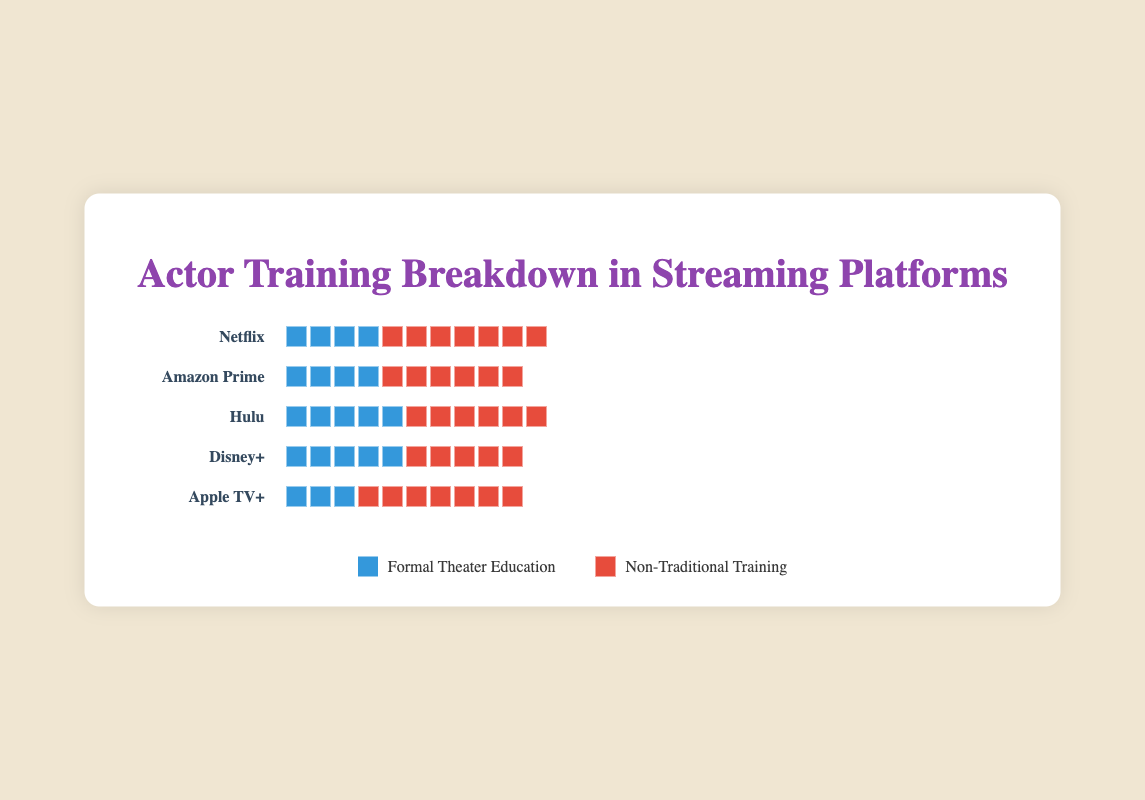Which streaming platform has the highest percentage of actors with formal theater education? To find this, look at each row and count the number of icons representing actors with formal theater education. The platform with the most icons in the "formal" category is Disney+ with 50 actors.
Answer: Disney+ What is the percentage difference in actors with non-traditional training between Netflix and Apple TV+? Count the icons for non-traditional training on both Netflix and Apple TV+. For Netflix, there are 65, and for Apple TV+, there are 70. The percentage difference is (70 - 65) / 100 * 100% = 5%.
Answer: 5% Which platform has an equal number of actors with formal theater education and non-traditional training? Look for a platform whose icons for formal theater education and non-traditional training are equal. Disney+ has 50 for each, making them equal.
Answer: Disney+ How many more actors have non-traditional training than formal theater education on Amazon Prime? On Amazon Prime, there are 40 icons for formal theater education and 60 for non-traditional training. Subtract formal from non-traditional to get 60 - 40 = 20 more actors with non-traditional training.
Answer: 20 Which streaming platform has the smallest total number of actors in the plot? To determine the smallest total number, add the formal theater education and non-traditional training for each platform. Apple TV+ has 30 + 70 = 100, which is the smallest total among all the platforms.
Answer: Apple TV+ What is the combined percentage of actors with formal theater education across all platforms? To get the total percentage, sum the formal theater education percentages for each platform (35 + 40 + 45 + 50 + 30) and divide by the number of platforms, which is 5. (35 + 40 + 45 + 50 + 30) / 5 = 40%.
Answer: 40% On which platform is the difference between actors with formal theater education and non-traditional training the largest? Calculate the differences for each platform: Netflix (65 - 35 = 30), Amazon Prime (60 - 40 = 20), Hulu (55 - 45 = 10), Disney+ (50 - 50 = 0), Apple TV+ (70 - 30 = 40). The largest difference is on Apple TV+ with 40.
Answer: Apple TV+ How many streaming platforms have more actors with non-traditional training than with formal theater education? Compare the counts of formal theater education and non-traditional training icons for each platform. Netflix, Amazon Prime, Hulu, and Apple TV+ have more actors with non-traditional training. This means 4 platforms fit the criteria.
Answer: 4 